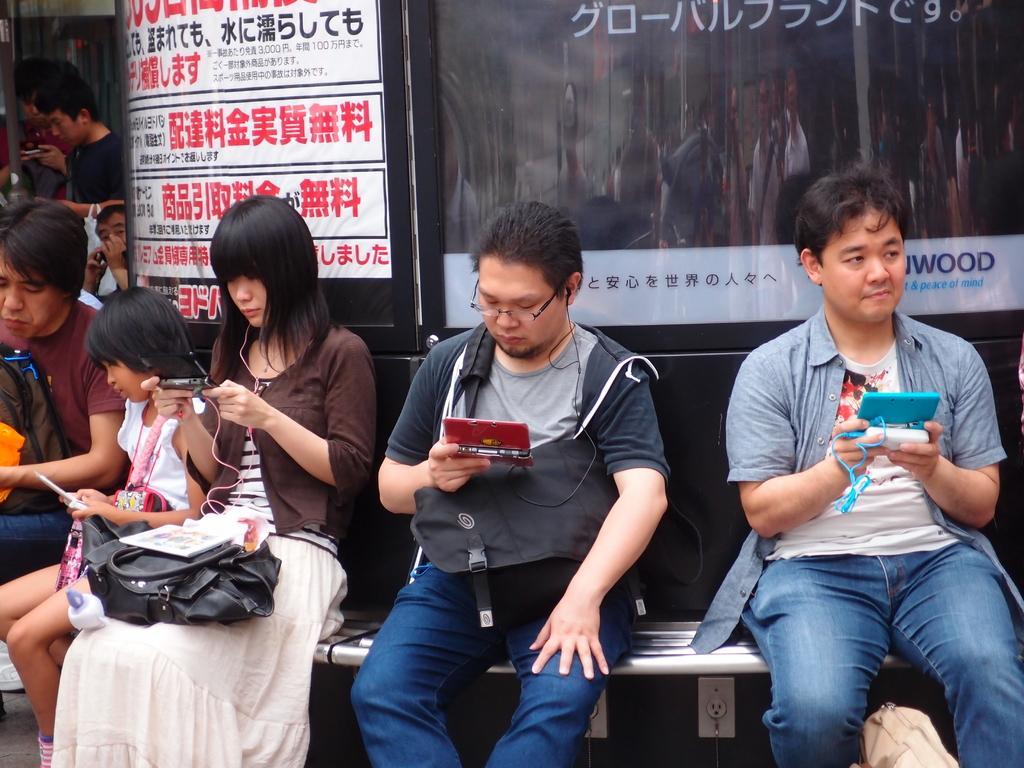Could you give a brief overview of what you see in this image? In this image there are a group of people who are sitting and some of them are standing and they are holding mobile phones, and on the background there is a wall and some posters are there on the wall. 